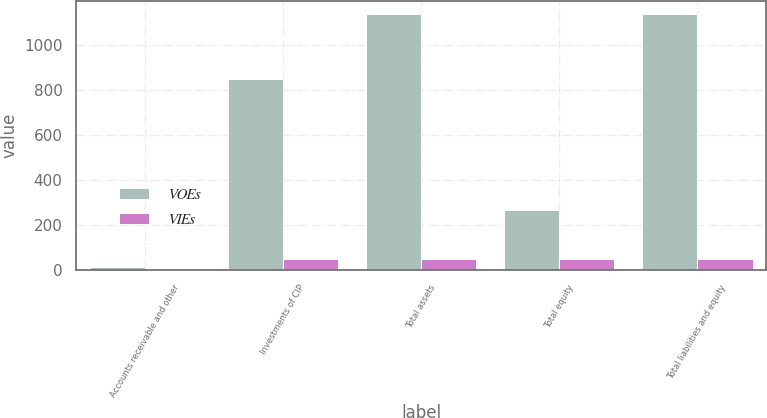Convert chart. <chart><loc_0><loc_0><loc_500><loc_500><stacked_bar_chart><ecel><fcel>Accounts receivable and other<fcel>Investments of CIP<fcel>Total assets<fcel>Total equity<fcel>Total liabilities and equity<nl><fcel>VOEs<fcel>11.5<fcel>851.8<fcel>1141.1<fcel>265.4<fcel>1141.1<nl><fcel>VIEs<fcel>0.2<fcel>49.8<fcel>50<fcel>50<fcel>50<nl></chart> 